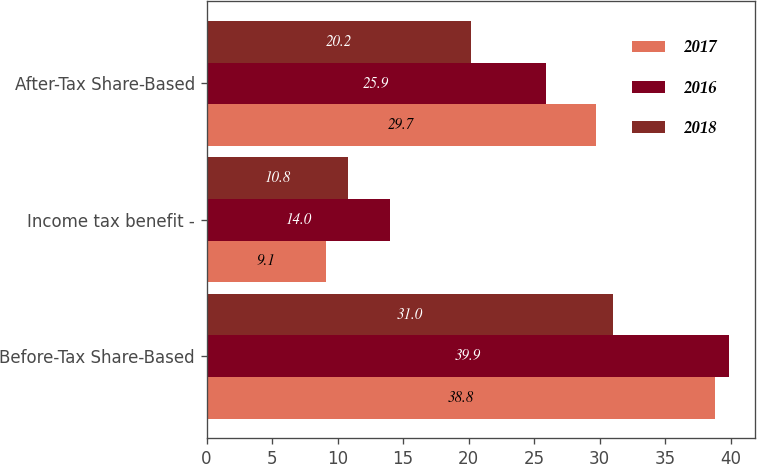<chart> <loc_0><loc_0><loc_500><loc_500><stacked_bar_chart><ecel><fcel>Before-Tax Share-Based<fcel>Income tax benefit -<fcel>After-Tax Share-Based<nl><fcel>2017<fcel>38.8<fcel>9.1<fcel>29.7<nl><fcel>2016<fcel>39.9<fcel>14<fcel>25.9<nl><fcel>2018<fcel>31<fcel>10.8<fcel>20.2<nl></chart> 